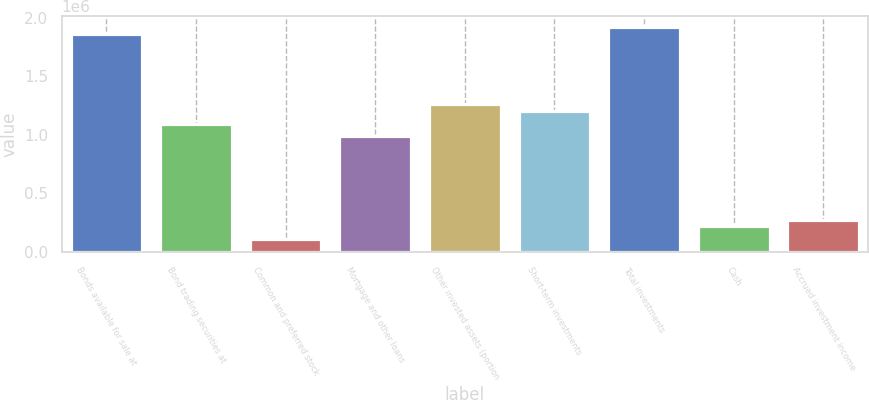Convert chart. <chart><loc_0><loc_0><loc_500><loc_500><bar_chart><fcel>Bonds available for sale at<fcel>Bond trading securities at<fcel>Common and preferred stock<fcel>Mortgage and other loans<fcel>Other invested assets (portion<fcel>Short-term investments<fcel>Total investments<fcel>Cash<fcel>Accrued investment income<nl><fcel>1.86455e+06<fcel>1.09693e+06<fcel>109994<fcel>987272<fcel>1.26142e+06<fcel>1.20659e+06<fcel>1.91938e+06<fcel>219654<fcel>274484<nl></chart> 